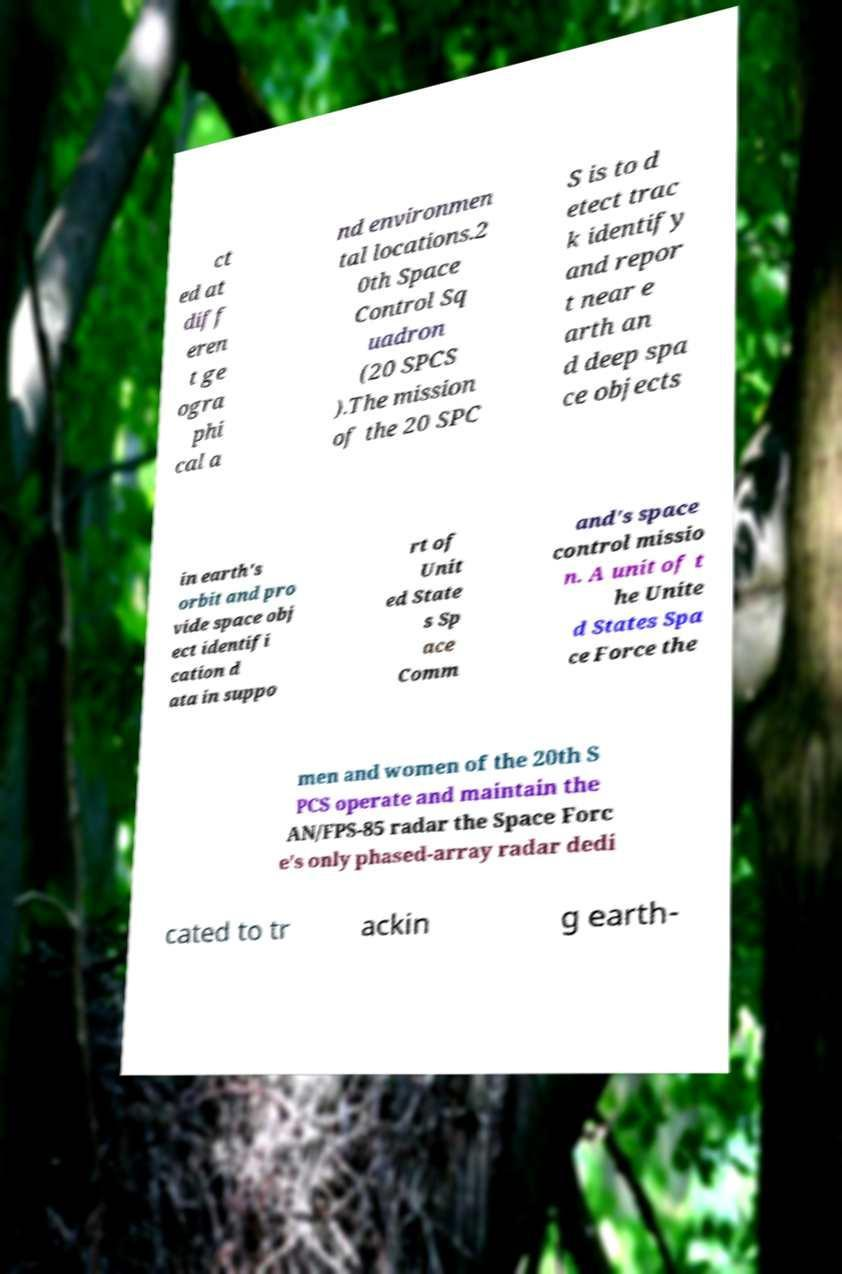Please read and relay the text visible in this image. What does it say? ct ed at diff eren t ge ogra phi cal a nd environmen tal locations.2 0th Space Control Sq uadron (20 SPCS ).The mission of the 20 SPC S is to d etect trac k identify and repor t near e arth an d deep spa ce objects in earth's orbit and pro vide space obj ect identifi cation d ata in suppo rt of Unit ed State s Sp ace Comm and's space control missio n. A unit of t he Unite d States Spa ce Force the men and women of the 20th S PCS operate and maintain the AN/FPS-85 radar the Space Forc e's only phased-array radar dedi cated to tr ackin g earth- 